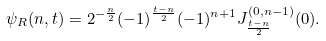<formula> <loc_0><loc_0><loc_500><loc_500>\psi _ { R } ( n , t ) = 2 ^ { - \frac { n } { 2 } } ( - 1 ) ^ { \frac { t - n } { 2 } } ( - 1 ) ^ { n + 1 } J _ { \frac { t - n } { 2 } } ^ { ( 0 , n - 1 ) } ( 0 ) .</formula> 